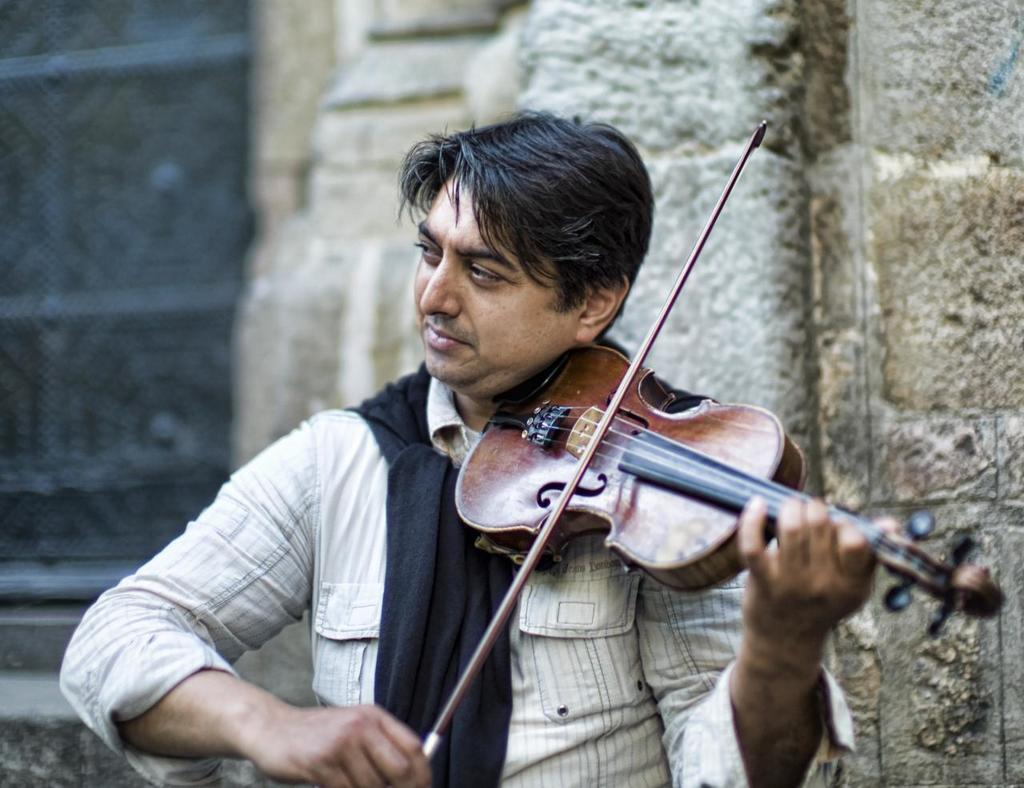Who is the person in the image? There is a man in the image. What is the man doing in the image? The man is playing a violin. Where is the man located in the image? The man is on the left side of the image. What can be seen in the background of the image? There is a wall in the background of the image. What is the man wearing on his upper body? The man is wearing a shirt. What accessory is the man wearing around his neck? The man is wearing a black color scarf around his neck. What type of crate is visible in the image? There is no crate present in the image. How many hydrants are visible in the image? There are no hydrants present in the image. 